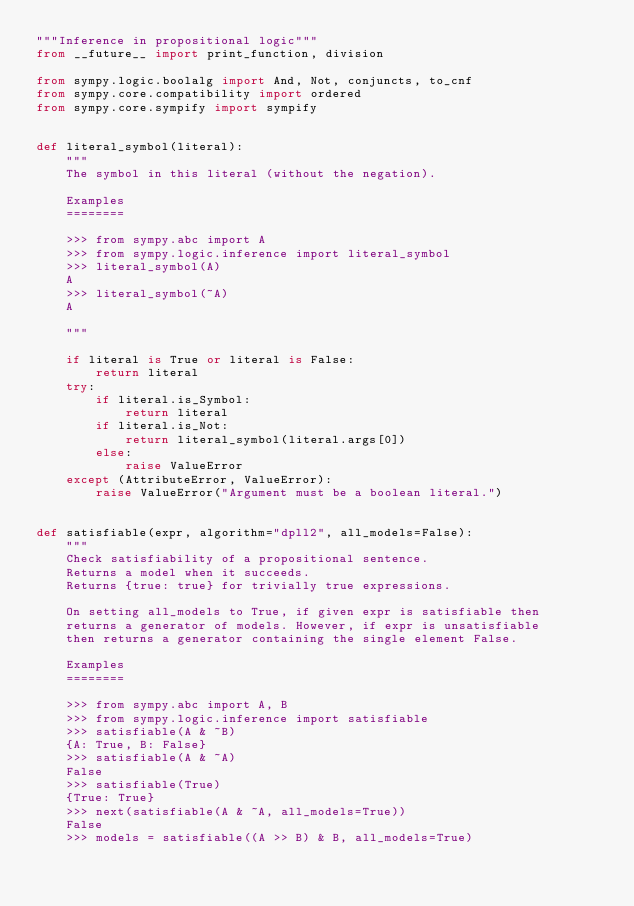Convert code to text. <code><loc_0><loc_0><loc_500><loc_500><_Python_>"""Inference in propositional logic"""
from __future__ import print_function, division

from sympy.logic.boolalg import And, Not, conjuncts, to_cnf
from sympy.core.compatibility import ordered
from sympy.core.sympify import sympify


def literal_symbol(literal):
    """
    The symbol in this literal (without the negation).

    Examples
    ========

    >>> from sympy.abc import A
    >>> from sympy.logic.inference import literal_symbol
    >>> literal_symbol(A)
    A
    >>> literal_symbol(~A)
    A

    """

    if literal is True or literal is False:
        return literal
    try:
        if literal.is_Symbol:
            return literal
        if literal.is_Not:
            return literal_symbol(literal.args[0])
        else:
            raise ValueError
    except (AttributeError, ValueError):
        raise ValueError("Argument must be a boolean literal.")


def satisfiable(expr, algorithm="dpll2", all_models=False):
    """
    Check satisfiability of a propositional sentence.
    Returns a model when it succeeds.
    Returns {true: true} for trivially true expressions.

    On setting all_models to True, if given expr is satisfiable then
    returns a generator of models. However, if expr is unsatisfiable
    then returns a generator containing the single element False.

    Examples
    ========

    >>> from sympy.abc import A, B
    >>> from sympy.logic.inference import satisfiable
    >>> satisfiable(A & ~B)
    {A: True, B: False}
    >>> satisfiable(A & ~A)
    False
    >>> satisfiable(True)
    {True: True}
    >>> next(satisfiable(A & ~A, all_models=True))
    False
    >>> models = satisfiable((A >> B) & B, all_models=True)</code> 